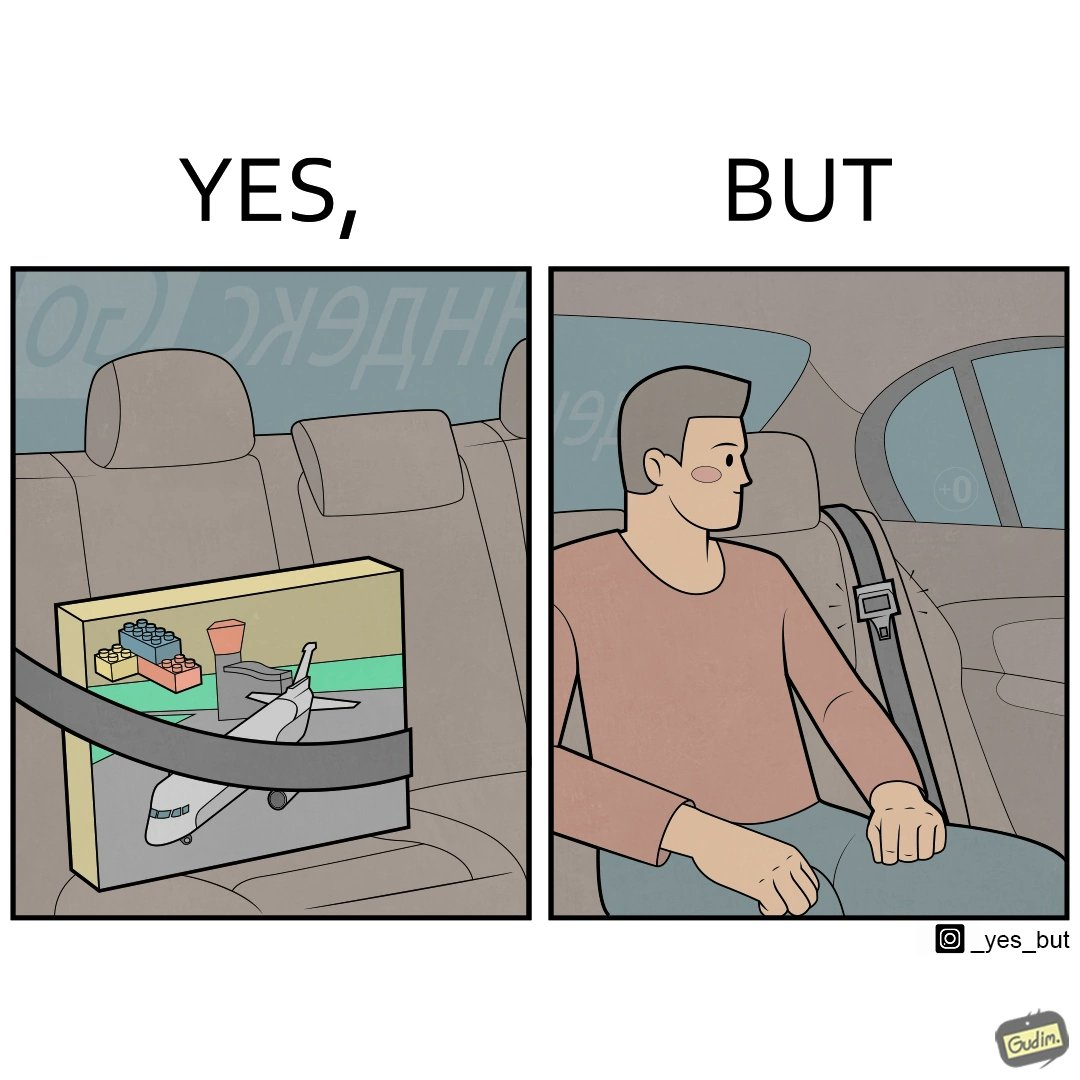Describe the contrast between the left and right parts of this image. In the left part of the image: A box of building blocks, secured by the seatbelt in the backseat of a car. In the right part of the image: A person sitting in the backseat of a car, not wearing a seatbelt 